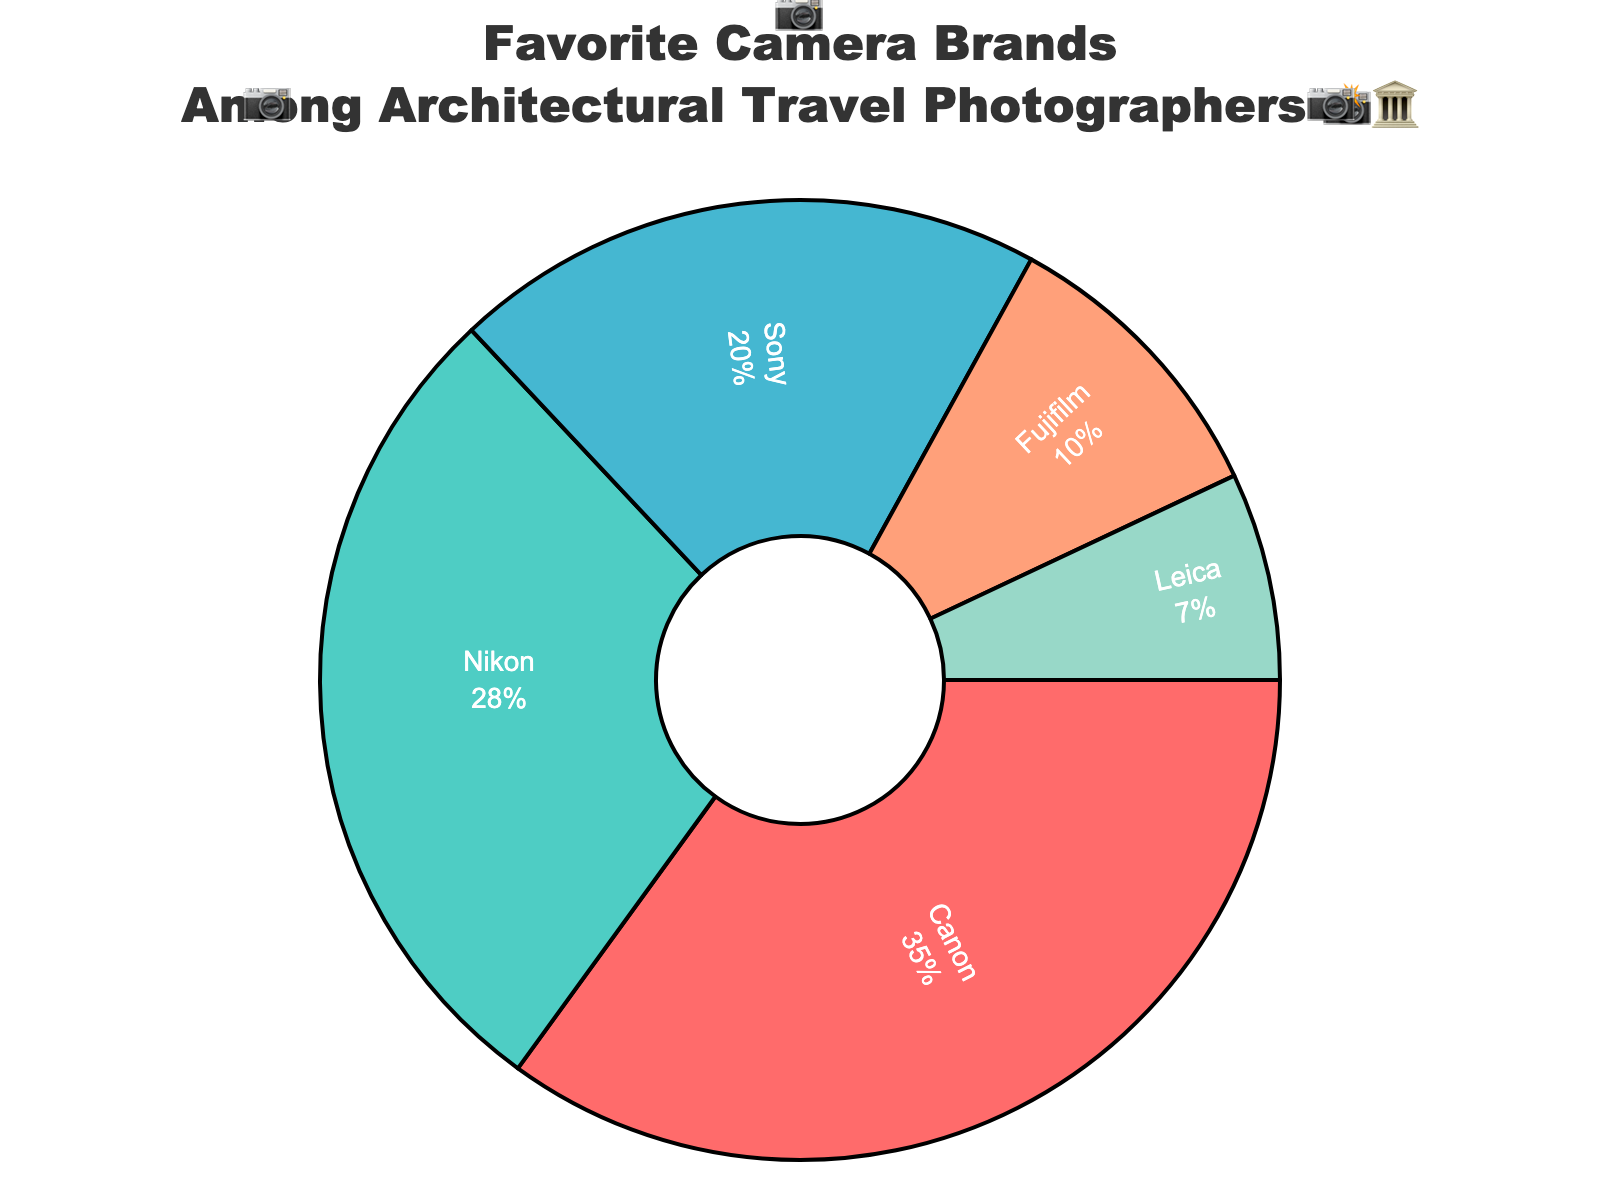What's the most favorite camera brand among travel photographers specializing in architectural shots? The title indicates we are looking at favorite camera brands among architectural travel photographers. The largest portion in the pie chart represents the most favorite brand. In this case, Canon occupies the largest slice with 35%.
Answer: Canon What percentage of photographers prefer Nikon? Each slice of the pie chart shows the percentage of photographers who prefer each brand. Nikon's slice shows 28%.
Answer: 28% Which brand has the smallest share among travel photographers? To determine the smallest share, look for the smallest slice in the pie chart. Leica, at 7%, is the smallest.
Answer: Leica What is the combined percentage of photographers who prefer Canon and Sony? Add the percentages of Canon (35%) and Sony (20%). 35 + 20 = 55%.
Answer: 55% How much more popular is Canon compared to Sony? Subtract Sony's percentage (20%) from Canon's percentage (35%). 35 - 20 = 15%.
Answer: 15% Which brand is more popular, Fujifilm or Leica, and by how much? Compare the percentages of Fujifilm (10%) and Leica (7%). Fujifilm is more popular. Subtract Leica's 7% from Fujifilm's 10%. 10 - 7 = 3%.
Answer: Fujifilm by 3% Are Canon and Nikon together favored by more than half of the photographers? Sum the percentages of both Canon (35%) and Nikon (28%). 35 + 28 = 63%. Since 63% is more than 50%, yes, they are favored by more than half.
Answer: Yes What is the total percentage of photographers preferring either Sony, Fujifilm, or Leica? Sum the percentages for Sony (20%), Fujifilm (10%), and Leica (7%). 20 + 10 + 7 = 37%.
Answer: 37% Is the sum of Fujifilm and Leica's percentages more significant than Nikon's? Add the percentages of Fujifilm (10%) and Leica (7%). 10 + 7 = 17%. Compare this with Nikon's 28%. Since 17% is less than 28%, the sum is not larger.
Answer: No How many camera emojis are there around the pie chart? Count the number of emojis placed around the pie chart. There are 12 camera emojis.
Answer: 12 